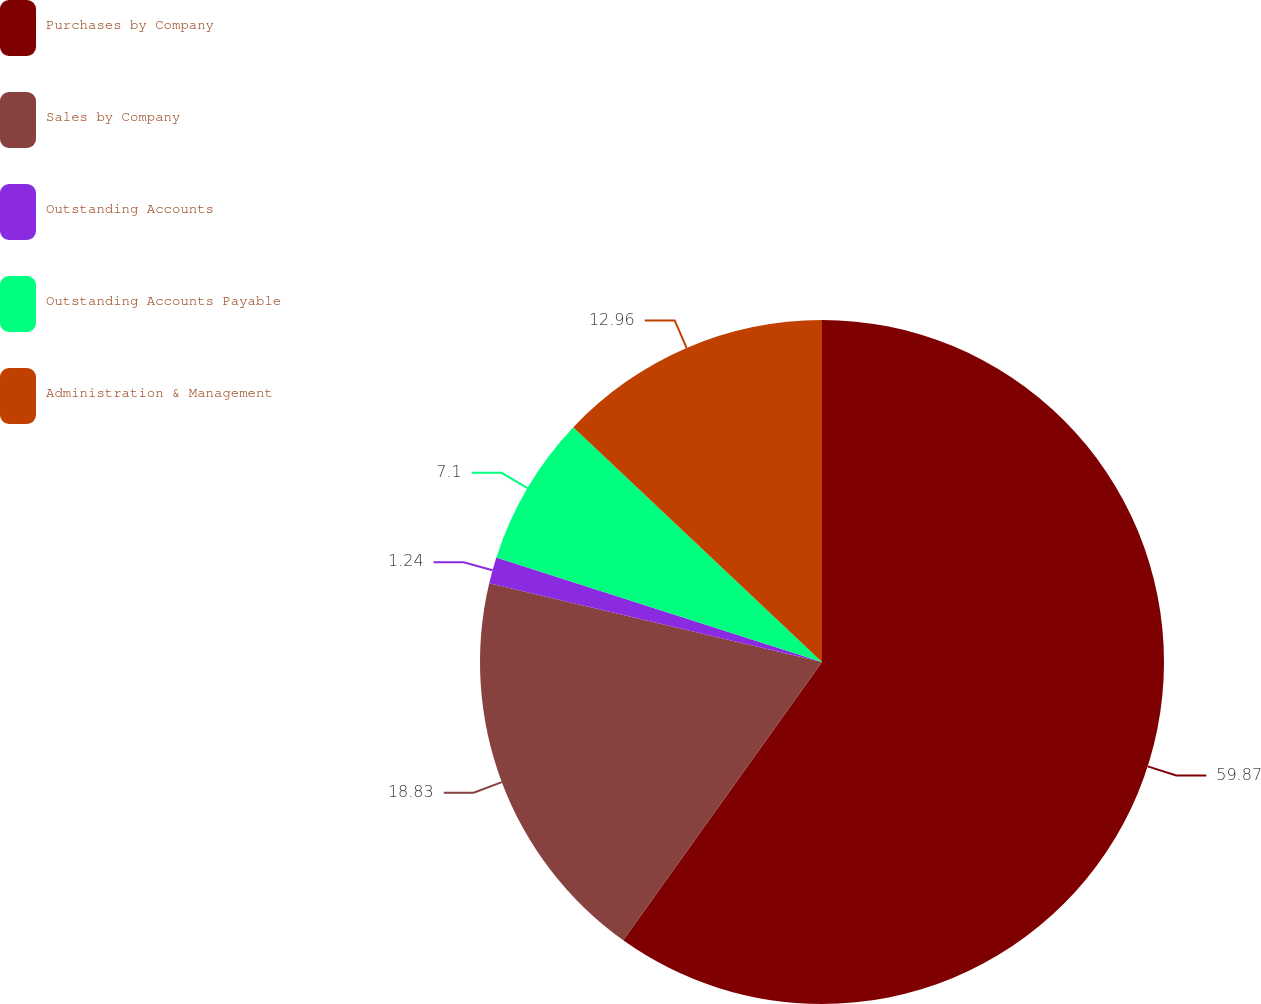Convert chart. <chart><loc_0><loc_0><loc_500><loc_500><pie_chart><fcel>Purchases by Company<fcel>Sales by Company<fcel>Outstanding Accounts<fcel>Outstanding Accounts Payable<fcel>Administration & Management<nl><fcel>59.87%<fcel>18.83%<fcel>1.24%<fcel>7.1%<fcel>12.96%<nl></chart> 